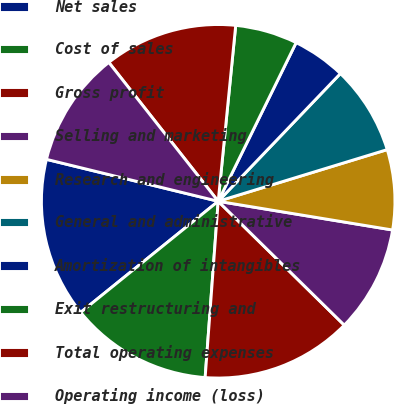Convert chart to OTSL. <chart><loc_0><loc_0><loc_500><loc_500><pie_chart><fcel>Net sales<fcel>Cost of sales<fcel>Gross profit<fcel>Selling and marketing<fcel>Research and engineering<fcel>General and administrative<fcel>Amortization of intangibles<fcel>Exit restructuring and<fcel>Total operating expenses<fcel>Operating income (loss)<nl><fcel>14.63%<fcel>13.01%<fcel>13.82%<fcel>9.76%<fcel>7.32%<fcel>8.13%<fcel>4.88%<fcel>5.69%<fcel>12.2%<fcel>10.57%<nl></chart> 